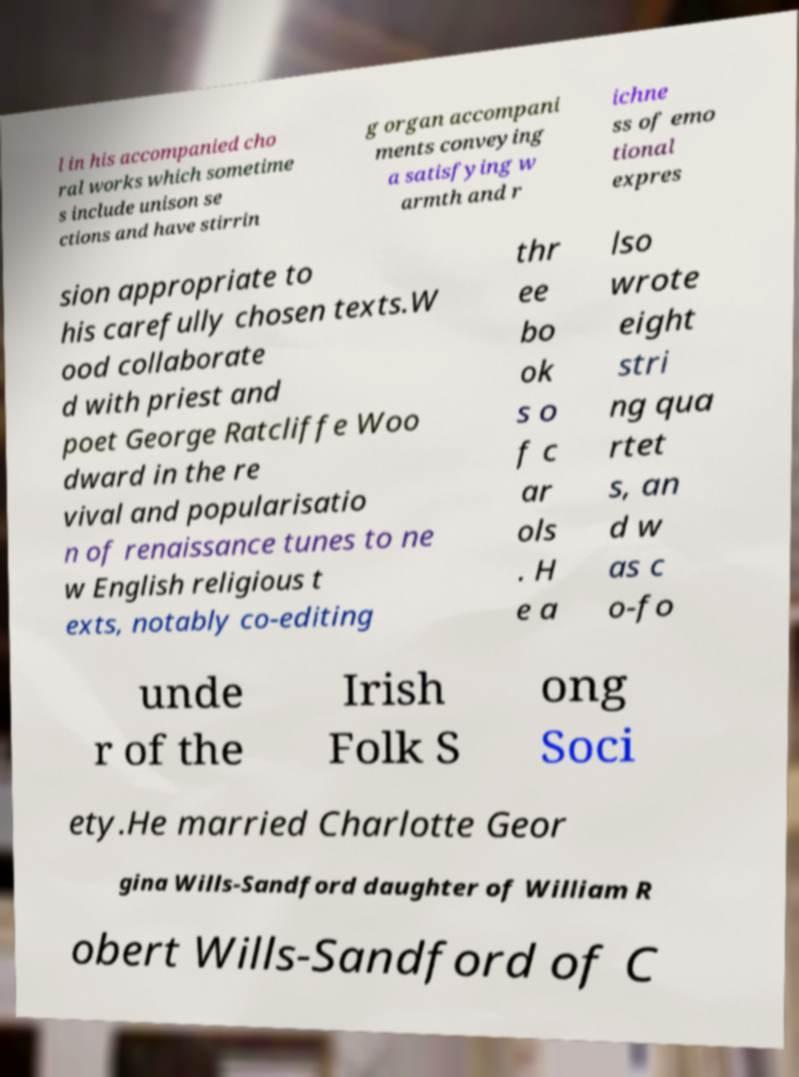Please identify and transcribe the text found in this image. l in his accompanied cho ral works which sometime s include unison se ctions and have stirrin g organ accompani ments conveying a satisfying w armth and r ichne ss of emo tional expres sion appropriate to his carefully chosen texts.W ood collaborate d with priest and poet George Ratcliffe Woo dward in the re vival and popularisatio n of renaissance tunes to ne w English religious t exts, notably co-editing thr ee bo ok s o f c ar ols . H e a lso wrote eight stri ng qua rtet s, an d w as c o-fo unde r of the Irish Folk S ong Soci ety.He married Charlotte Geor gina Wills-Sandford daughter of William R obert Wills-Sandford of C 